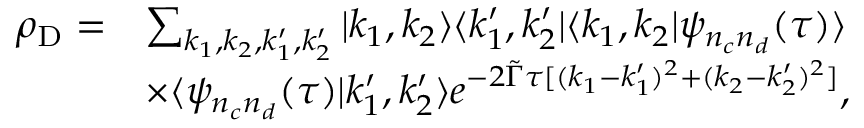<formula> <loc_0><loc_0><loc_500><loc_500>\begin{array} { r l } { \rho _ { D } = } & { \sum _ { k _ { 1 } , k _ { 2 } , k _ { 1 } ^ { \prime } , k _ { 2 } ^ { \prime } } | k _ { 1 } , k _ { 2 } \rangle \langle k _ { 1 } ^ { \prime } , k _ { 2 } ^ { \prime } | \langle k _ { 1 } , k _ { 2 } | \psi _ { n _ { c } n _ { d } } ( \tau ) \rangle } \\ & { \times \langle \psi _ { n _ { c } n _ { d } } ( \tau ) | k _ { 1 } ^ { \prime } , k _ { 2 } ^ { \prime } \rangle e ^ { - 2 \tilde { \Gamma } \tau [ ( k _ { 1 } - k _ { 1 } ^ { \prime } ) ^ { 2 } + ( k _ { 2 } - k _ { 2 } ^ { \prime } ) ^ { 2 } ] } , } \end{array}</formula> 